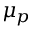<formula> <loc_0><loc_0><loc_500><loc_500>\mu _ { p }</formula> 